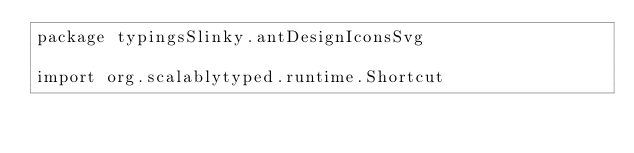Convert code to text. <code><loc_0><loc_0><loc_500><loc_500><_Scala_>package typingsSlinky.antDesignIconsSvg

import org.scalablytyped.runtime.Shortcut</code> 